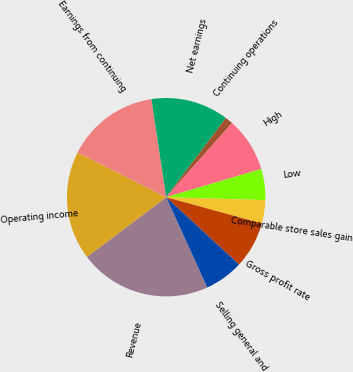Convert chart to OTSL. <chart><loc_0><loc_0><loc_500><loc_500><pie_chart><fcel>Revenue<fcel>Operating income<fcel>Earnings from continuing<fcel>Net earnings<fcel>Continuing operations<fcel>High<fcel>Low<fcel>Comparable store sales gain<fcel>Gross profit rate<fcel>Selling general and<nl><fcel>21.52%<fcel>17.72%<fcel>15.19%<fcel>12.66%<fcel>1.27%<fcel>8.86%<fcel>5.06%<fcel>3.8%<fcel>7.6%<fcel>6.33%<nl></chart> 